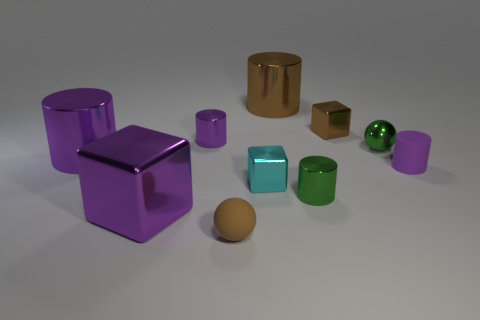What can the arrangement of these shapes tell us about volume and space? The arrangement of the shapes presents an excellent opportunity to discuss concepts of volume and space. The larger shapes, such as the purple cube and the cylinder, take up more visible space, while the smaller cubes and sphere occupy less, demonstrating how size affects the perception of volume. There appears to be a deliberate space left between each object, which highlights their individual volumes and allows for an estimation of their relative sizes and the space they occupy. 